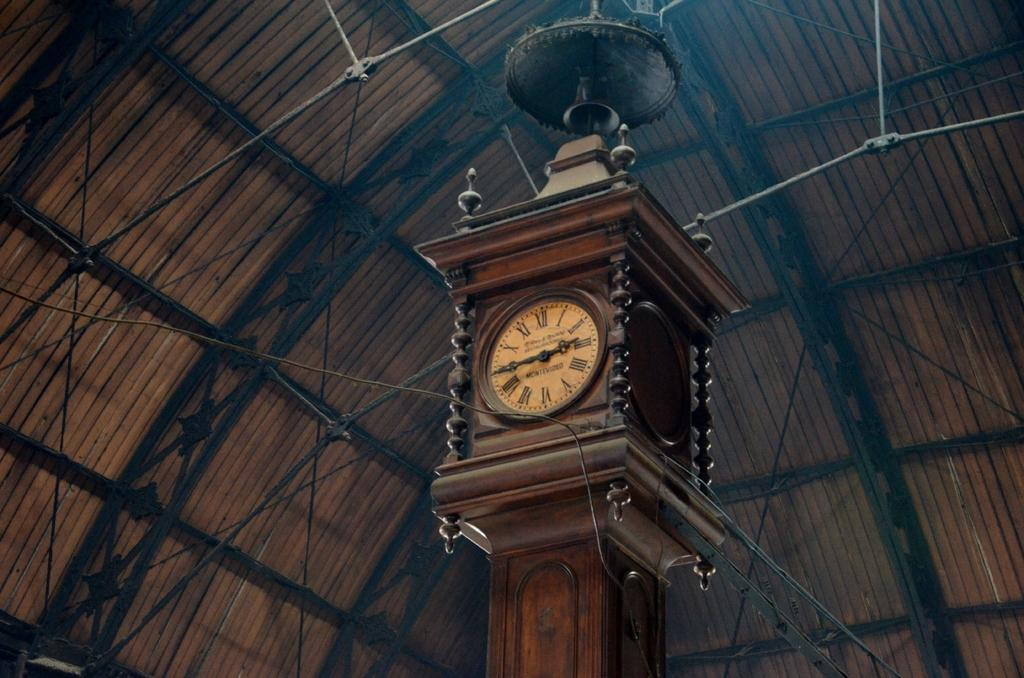<image>
Create a compact narrative representing the image presented. the Montevideo clock tower stands tall and proud 